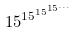Convert formula to latex. <formula><loc_0><loc_0><loc_500><loc_500>1 5 ^ { 1 5 ^ { 1 5 ^ { 1 5 ^ { \dots } } } }</formula> 